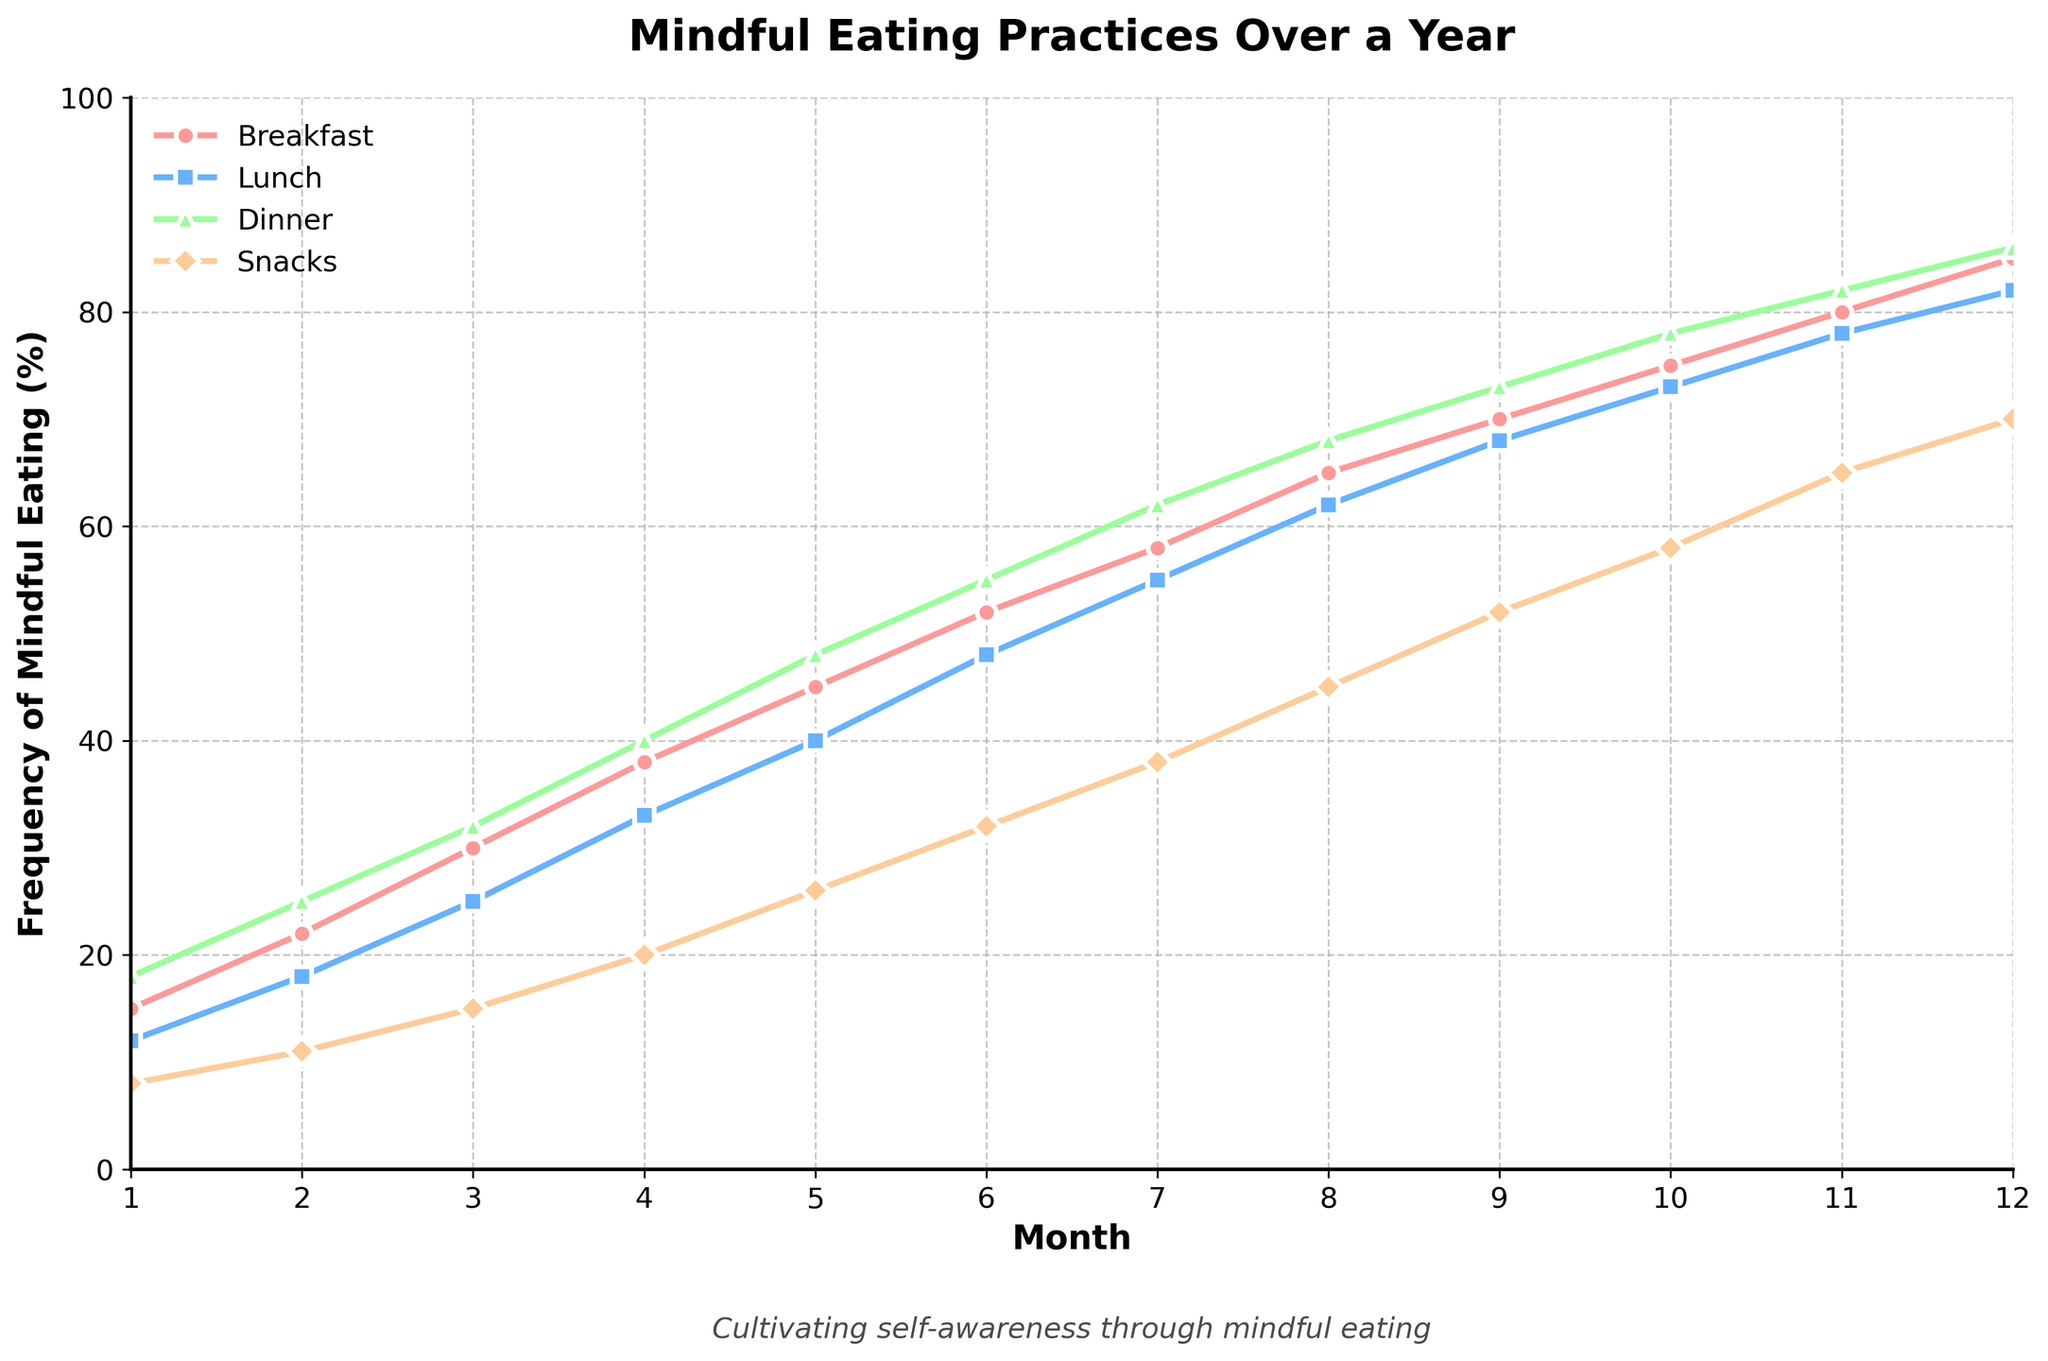what is the frequency of mindful eating during breakfast in Month 6? The plot shows the frequency progression over 12 months for various meal types. In Month 6, the frequency for breakfast can be found at the intersection of Month 6 on the X-axis and the line representing breakfast. The frequency reads as 52%.
Answer: 52% Compare the frequency of mindful eating during lunch in Month 3 and Month 9. Which month had a higher rate? The line for lunch shows a progression for each month. For Month 3, it’s 25%, and for Month 9, it’s 68%. Comparing both values, Month 9 had a higher rate of mindful eating.
Answer: Month 9 What is the difference in the frequency of mindful eating during snacks between Month 1 and Month 12? Identify the values from the snacks line for both months. Month 1 has 8% and Month 12 has 70%. Calculating the difference: 70% - 8% = 62%.
Answer: 62% Which meal type showed the highest frequency increase from Month 1 to Month 12? Check the starting and ending values for each meal type. Breakfast increased from 15% to 85% (70% increase), Lunch from 12% to 82% (70%), Dinner from 18% to 86% (68%), Snacks from 8% to 70% (62%). Breakfast and Lunch both show the highest increase.
Answer: Breakfast and Lunch What is the average frequency of mindful eating during dinner over the first six months? Find values for dinner in months 1-6: 18%, 25%, 32%, 40%, 48%, 55%. Calculate their sum: 18 + 25 + 32 + 40 + 48 + 55 = 218. Then divide by 6: 218/6 ≈ 36.33%.
Answer: 36.33% Is there a month where the frequency of mindful eating for dinner surpasses 80%? If yes, which month(s)? Examine the dinner trend line for values ≥80%. The data shows supper passing 80% in Month 11 (82%) and Month 12 (86%).
Answer: Month 11 and Month 12 Between which consecutive months does the frequency of mindful eating for snacks show the largest increase? Calculate increases for snacks: M2-M1: 3%, M3-M2: 4%, M4-M3: 5%, M5-M4: 6%, M6-M5: 6%, M7-M6: 6%, M8-M7: 7%, M9-M8: 7%, M10-M9: 6%, M11-M10: 7%, M12-M11: 5%. Months 8 to 9 show an increase of 7%, which is the largest.
Answer: Between Month 8 and Month 9 